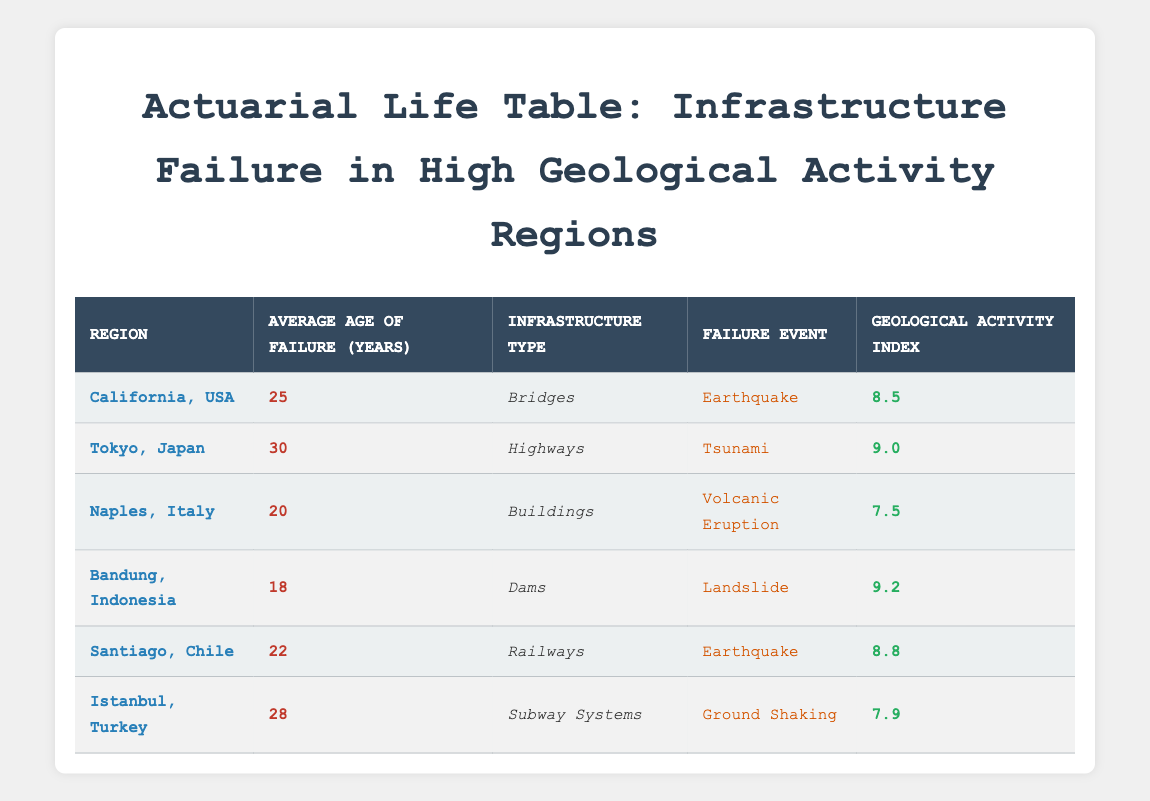What is the average age of failure for bridges in California? The table indicates that the average age of failure for bridges in California is listed directly as 25 years.
Answer: 25 years Which region has the highest geological activity index? By comparing the geological activity indexes in the table, Tokyo, Japan has the highest index at 9.0.
Answer: Tokyo, Japan What is the average age of failure for all the infrastructures listed in the table? To find the average, sum the average ages of failure for all listed infrastructures: (25 + 30 + 20 + 18 + 22 + 28) = 173. There are 6 entries, so the average is 173/6 = 28.83, rounded down gives us 28.
Answer: 28 years Is the average age of failure for dams less than 20 years? The table shows that the average age of failure for dams is 18 years, which confirms that it is indeed less than 20 years.
Answer: Yes Which failure event has the longest average age of failure among the listed infrastructures? By checking the ages: Earthquake (California - 25, Chile - 22), Tsunami (Tokyo - 30), Volcanic Eruption (Naples - 20), Landslide (Bandung - 18) and Ground Shaking (Istanbul - 28), the tsunami in Tokyo has the longest average age of failure at 30 years.
Answer: Tsunami What is the difference in average age of failure between buildings in Naples, Italy and dams in Bandung, Indonesia? The average age of failure for buildings in Naples is 20 years and for dams in Bandung, it is 18 years. The difference is 20 - 18 = 2 years.
Answer: 2 years How many infrastructures have an average age of failure greater than 24 years? Looking at the table, the infrastructures with over 24 years of failure are the highways in Tokyo (30 years), the subway systems in Istanbul (28 years), and the bridges in California (25 years), totaling three infrastructures.
Answer: 3 Where is the infrastructure failure event due to a volcanic eruption located? The table specifies that the infrastructure failure event due to a volcanic eruption occurs in Naples, Italy.
Answer: Naples, Italy Is the average failure age of railways less than that of highways? The average age of failure for railways in Santiago is 22 years, while for highways in Tokyo, it is 30 years. Thus, railways do have a lower average age of failure.
Answer: Yes 